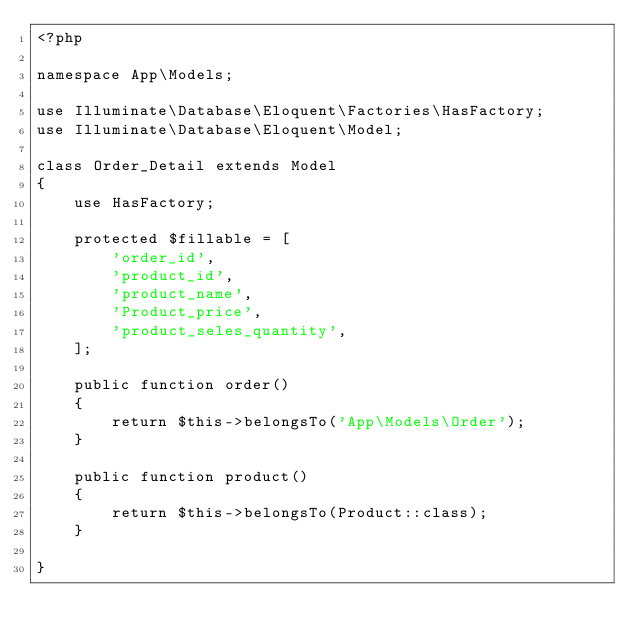<code> <loc_0><loc_0><loc_500><loc_500><_PHP_><?php

namespace App\Models;

use Illuminate\Database\Eloquent\Factories\HasFactory;
use Illuminate\Database\Eloquent\Model;

class Order_Detail extends Model
{
    use HasFactory;

    protected $fillable = [
        'order_id',
        'product_id',
        'product_name',
        'Product_price',
        'product_seles_quantity',
    ];

    public function order()
    {
        return $this->belongsTo('App\Models\Order');
    }

    public function product()
    {
        return $this->belongsTo(Product::class);
    }
    
}
</code> 